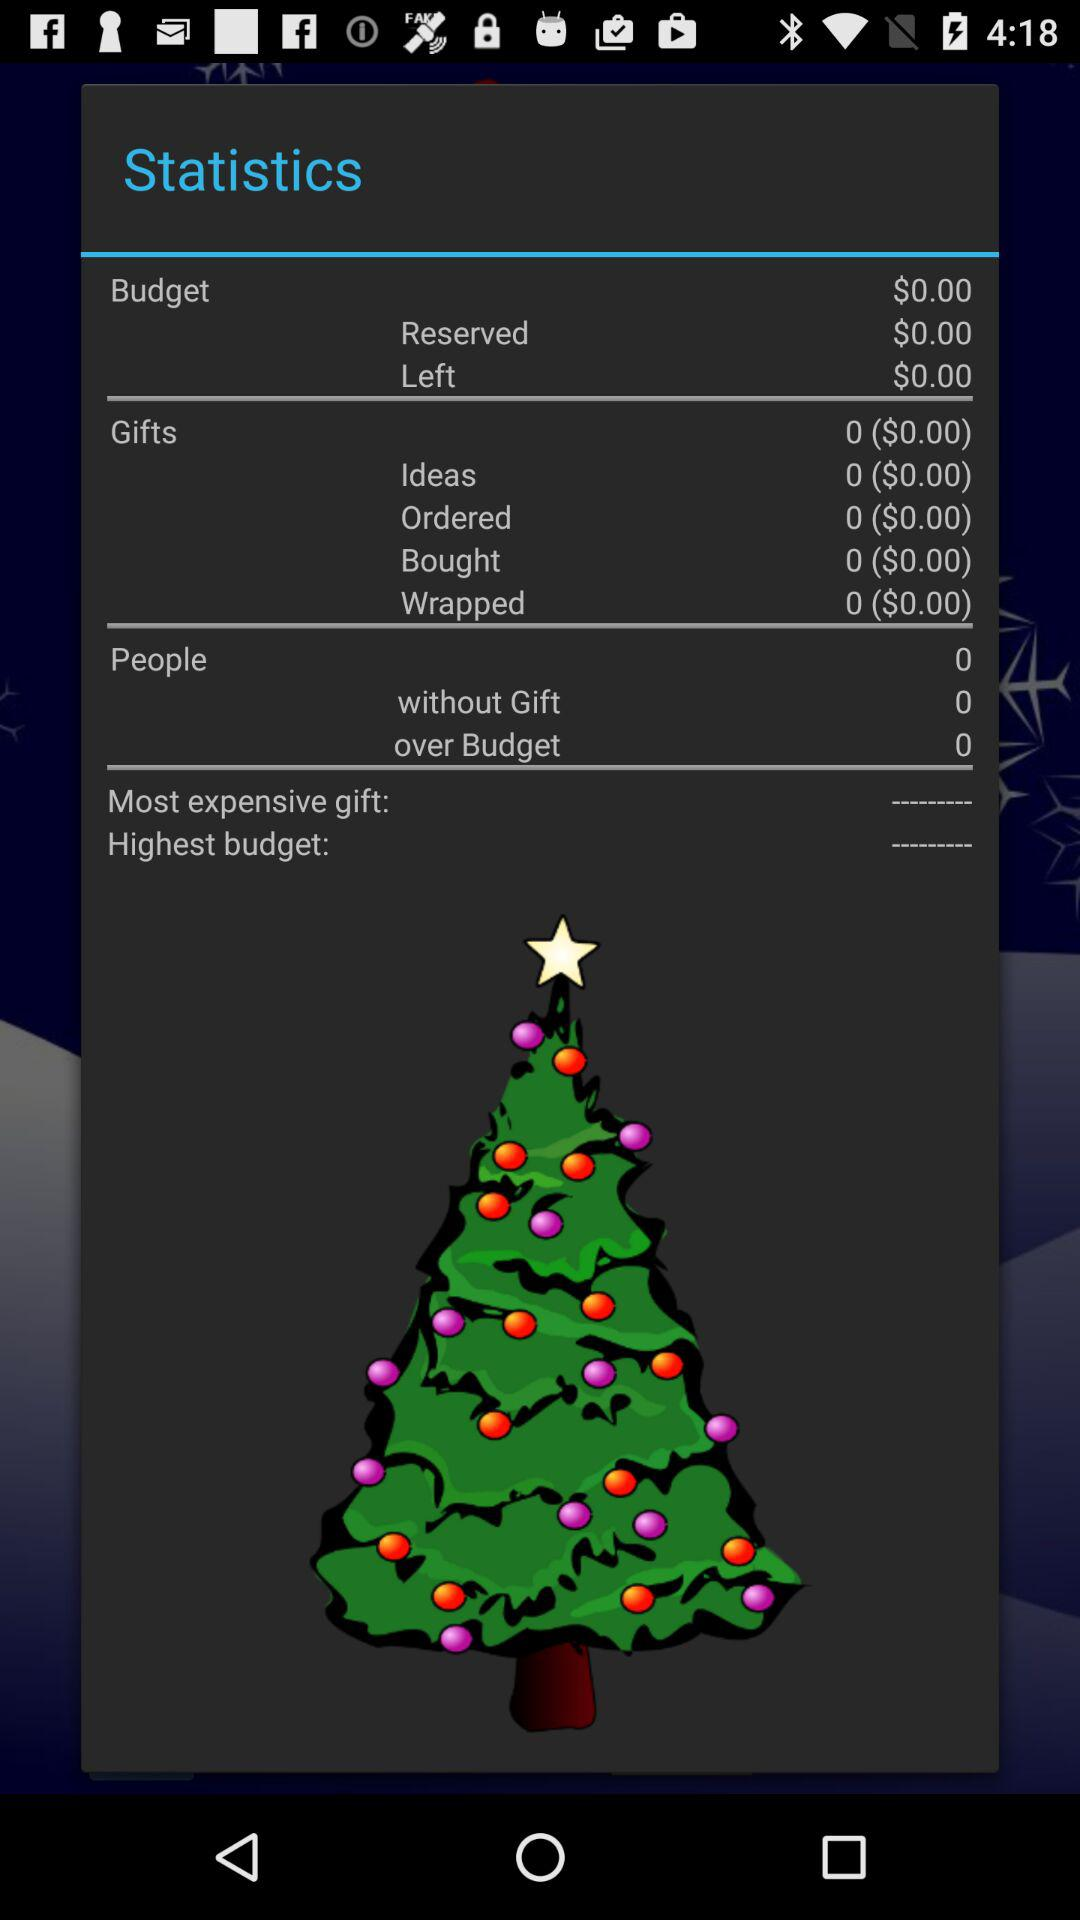How many people are over budget?
Answer the question using a single word or phrase. 0 